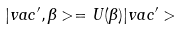Convert formula to latex. <formula><loc_0><loc_0><loc_500><loc_500>| v a c ^ { \prime } , \beta > = U ( \beta ) | v a c ^ { \prime } ></formula> 